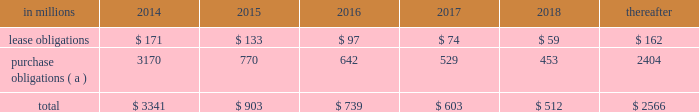At december 31 , 2013 , total future minimum commitments under existing non-cancelable operating leases and purchase obligations were as follows: .
( a ) includes $ 3.3 billion relating to fiber supply agreements entered into at the time of the company 2019s 2006 transformation plan forestland sales and in conjunction with the 2008 acquisition of weyerhaeuser company 2019s containerboard , packaging and recycling business .
Rent expense was $ 215 million , $ 231 million and $ 205 million for 2013 , 2012 and 2011 , respectively .
Guarantees in connection with sales of businesses , property , equipment , forestlands and other assets , international paper commonly makes representations and warranties relating to such businesses or assets , and may agree to indemnify buyers with respect to tax and environmental liabilities , breaches of representations and warranties , and other matters .
Where liabilities for such matters are determined to be probable and subject to reasonable estimation , accrued liabilities are recorded at the time of sale as a cost of the transaction .
Environmental proceedings international paper has been named as a potentially responsible party in environmental remediation actions under various federal and state laws , including the comprehensive environmental response , compensation and liability act ( cercla ) .
Many of these proceedings involve the cleanup of hazardous substances at large commercial landfills that received waste from many different sources .
While joint and several liability is authorized under cercla and equivalent state laws , as a practical matter , liability for cercla cleanups is typically allocated among the many potential responsible parties .
Remedial costs are recorded in the consolidated financial statements when they become probable and reasonably estimable .
International paper has estimated the probable liability associated with these matters to be approximately $ 94 million in the aggregate at december 31 , 2013 .
Cass lake : one of the matters referenced above is a closed wood treating facility located in cass lake , minnesota .
During 2009 , in connection with an environmental site remediation action under cercla , international paper submitted to the epa a site remediation feasibility study .
In june 2011 , the epa selected and published a proposed soil remedy at the site with an estimated cost of $ 46 million .
The overall remediation reserve for the site is currently $ 51 million to address this selection of an alternative for the soil remediation component of the overall site remedy .
In october 2011 , the epa released a public statement indicating that the final soil remedy decision would be delayed .
In the unlikely event that the epa changes its proposed soil remedy and approves instead a more expensive clean-up alternative , the remediation costs could be material , and significantly higher than amounts currently recorded .
In october 2012 , the natural resource trustees for this site provided notice to international paper and other potentially responsible parties of their intent to perform a natural resource damage assessment .
It is premature to predict the outcome of the assessment or to estimate a loss or range of loss , if any , which may be incurred .
Other : in addition to the above matters , other remediation costs typically associated with the cleanup of hazardous substances at the company 2019s current , closed or formerly-owned facilities , and recorded as liabilities in the balance sheet , totaled approximately $ 42 million at december 31 , 2013 .
Other than as described above , completion of required remedial actions is not expected to have a material effect on our consolidated financial statements .
Kalamazoo river : the company is a potentially responsible party with respect to the allied paper , inc./ portage creek/kalamazoo river superfund site ( kalamazoo river superfund site ) in michigan .
The epa asserts that the site is contaminated primarily by pcbs as a result of discharges from various paper mills located along the kalamazoo river , including a paper mill formerly owned by st .
Regis paper company ( st .
Regis ) .
The company is a successor in interest to st .
Regis .
The company has not received any orders from the epa with respect to the site and continues to collect information from the epa and other parties relative to the site to evaluate the extent of its liability , if any , with respect to the site .
Accordingly , it is premature to estimate a loss or range of loss with respect to this site .
Also in connection with the kalamazoo river superfund site , the company was named as a defendant by georgia-pacific consumer products lp , fort james corporation and georgia pacific llc in a contribution and cost recovery action for alleged pollution at the site .
The suit seeks contribution under cercla for $ 79 million in costs purportedly expended by plaintiffs as of the filing of the complaint and for future remediation costs .
The suit alleges that a mill , during the time it was allegedly owned and operated by st .
Regis , discharged pcb contaminated solids and paper residuals resulting from paper de-inking and recycling .
Also named as defendants in the suit are ncr corporation and weyerhaeuser company .
In mid-2011 , the suit was transferred from the district court for the eastern district of wisconsin to the district court for the western .
In 2015 what percentage of at december 31 , 2013 , total future minimum commitments under existing non-cancelable operating leases and purchase obligations is due to purchase obligations? 
Computations: (770 / 903)
Answer: 0.85271. 